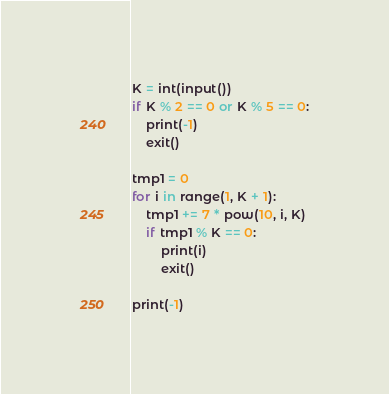<code> <loc_0><loc_0><loc_500><loc_500><_Python_>K = int(input())
if K % 2 == 0 or K % 5 == 0:
    print(-1)
    exit()

tmp1 = 0
for i in range(1, K + 1):
    tmp1 += 7 * pow(10, i, K)
    if tmp1 % K == 0:
        print(i)
        exit()

print(-1)</code> 